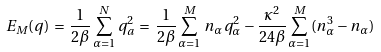<formula> <loc_0><loc_0><loc_500><loc_500>E _ { M } ( { q } ) \, = \, \frac { 1 } { 2 \beta } \sum _ { \alpha = 1 } ^ { N } q _ { a } ^ { 2 } \, = \, \frac { 1 } { 2 \beta } \sum _ { \alpha = 1 } ^ { M } \, n _ { \alpha } q _ { \alpha } ^ { 2 } - \frac { \kappa ^ { 2 } } { 2 4 \beta } \sum _ { \alpha = 1 } ^ { M } ( n _ { \alpha } ^ { 3 } - n _ { \alpha } )</formula> 